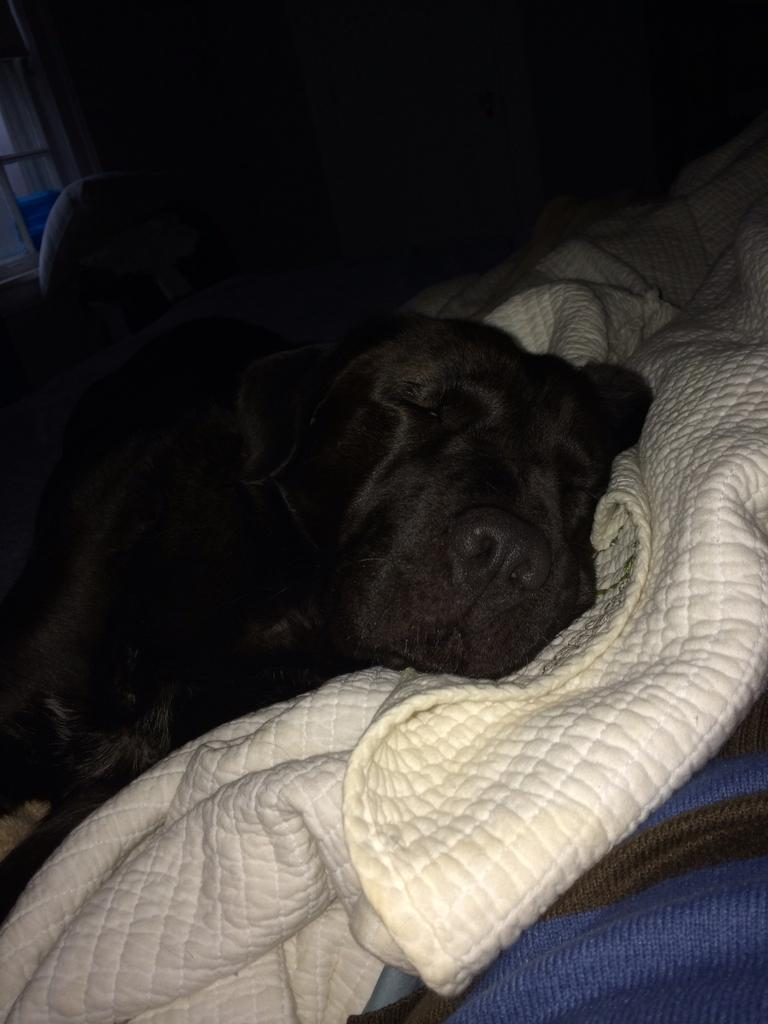What type of animal is present in the image? There is a dog in the image. What is the dog doing in the image? The dog is sleeping. What is the dog resting on in the image? The dog is on a white blanket. What color is the object at the bottom of the image? There is a blue color object at the bottom of the image. What type of alarm is the dog controlling in the image? There is no alarm present in the image, and the dog is not controlling anything. 